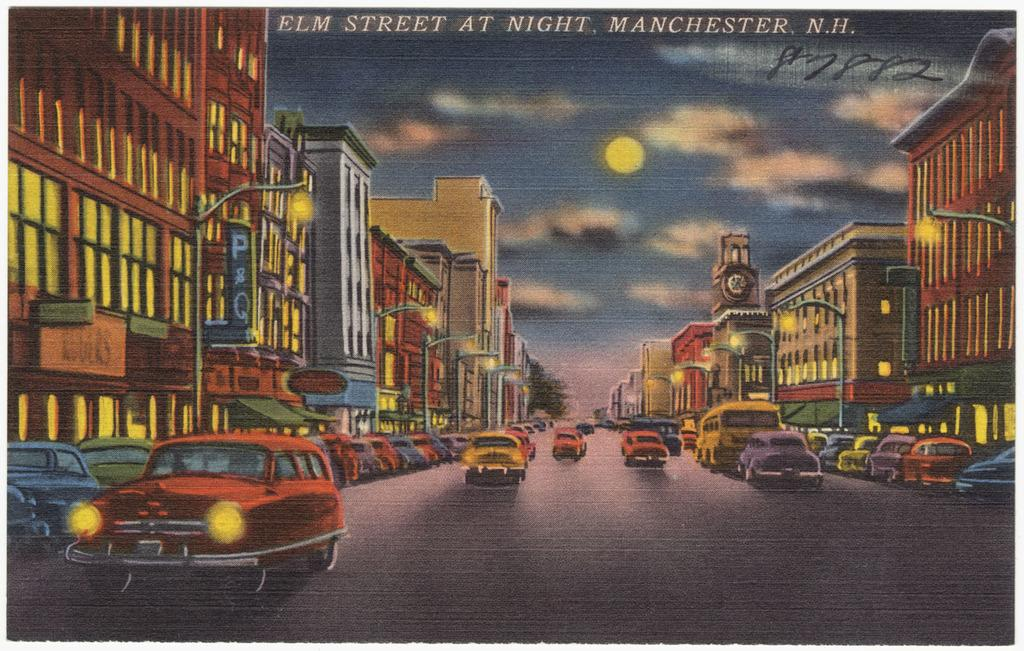Provide a one-sentence caption for the provided image. Cars go by on a busy city street in Manchester, N.H. 